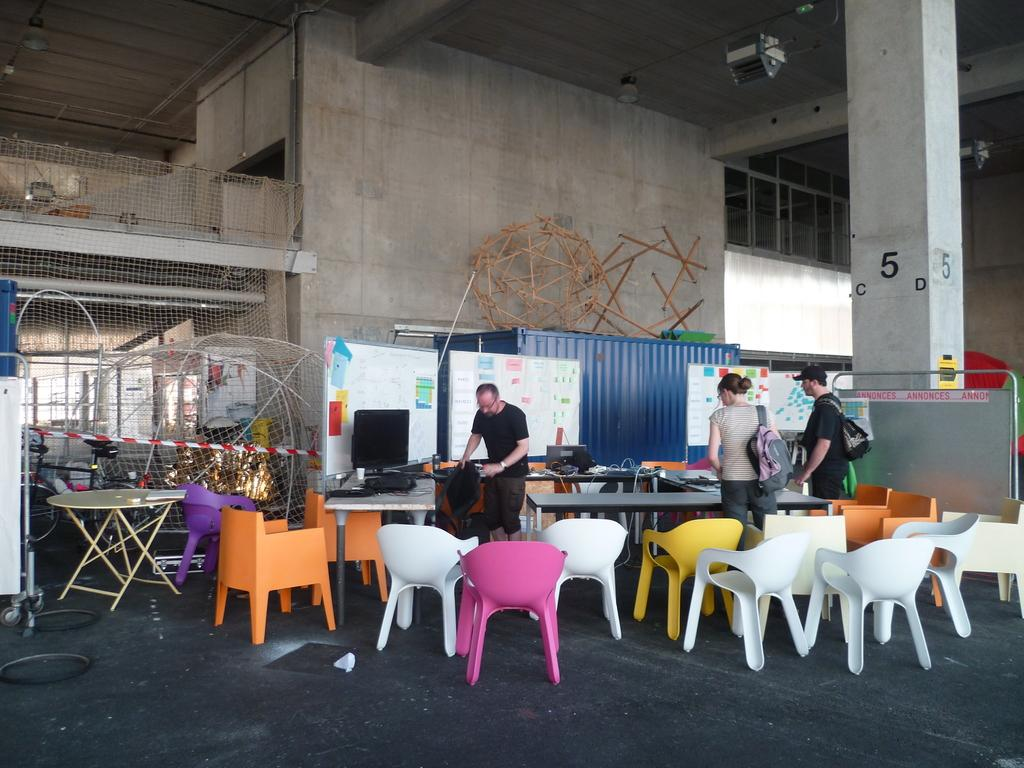What type of furniture is present in the room? There are chairs and tables in the room. How many people are in the room? There are three people in the room: two men and one woman. What is the woman carrying? The woman is carrying a bag. Can you describe any architectural features or designs visible in the image? Yes, there is an architectural feature or design visible in the image. What does the head of the woman hope to achieve in the image? There is no indication of the woman's head or her hopes in the image. 